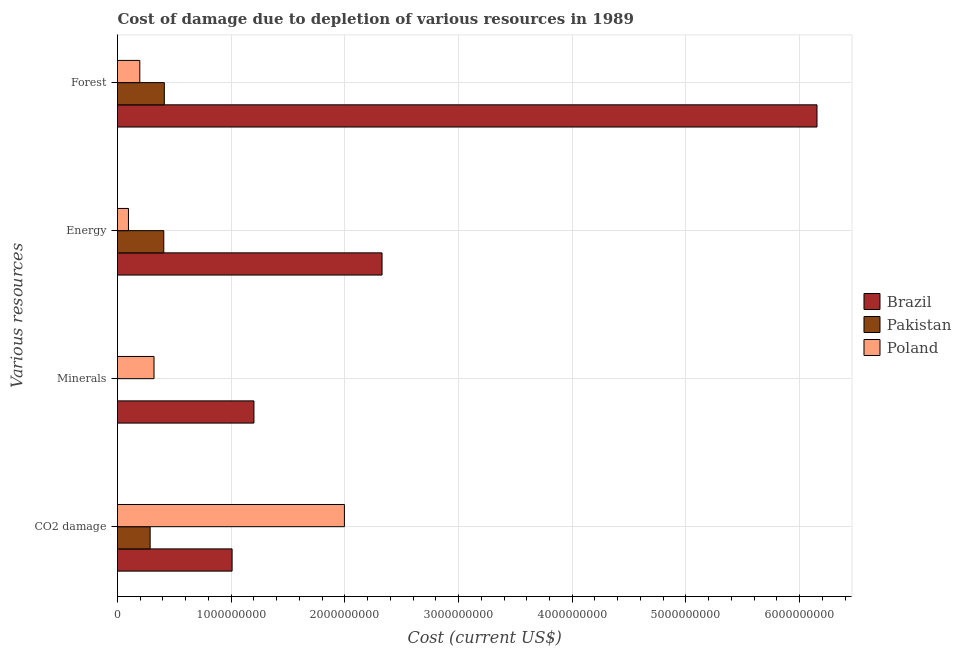How many different coloured bars are there?
Offer a very short reply. 3. How many groups of bars are there?
Provide a short and direct response. 4. Are the number of bars per tick equal to the number of legend labels?
Provide a succinct answer. Yes. How many bars are there on the 3rd tick from the bottom?
Make the answer very short. 3. What is the label of the 1st group of bars from the top?
Give a very brief answer. Forest. What is the cost of damage due to depletion of minerals in Pakistan?
Keep it short and to the point. 2.33e+04. Across all countries, what is the maximum cost of damage due to depletion of energy?
Offer a terse response. 2.33e+09. Across all countries, what is the minimum cost of damage due to depletion of minerals?
Your response must be concise. 2.33e+04. What is the total cost of damage due to depletion of minerals in the graph?
Offer a terse response. 1.52e+09. What is the difference between the cost of damage due to depletion of coal in Poland and that in Pakistan?
Ensure brevity in your answer.  1.71e+09. What is the difference between the cost of damage due to depletion of coal in Pakistan and the cost of damage due to depletion of minerals in Brazil?
Offer a very short reply. -9.13e+08. What is the average cost of damage due to depletion of forests per country?
Your response must be concise. 2.25e+09. What is the difference between the cost of damage due to depletion of minerals and cost of damage due to depletion of coal in Pakistan?
Provide a short and direct response. -2.87e+08. What is the ratio of the cost of damage due to depletion of coal in Poland to that in Brazil?
Give a very brief answer. 1.98. Is the difference between the cost of damage due to depletion of forests in Pakistan and Brazil greater than the difference between the cost of damage due to depletion of energy in Pakistan and Brazil?
Provide a succinct answer. No. What is the difference between the highest and the second highest cost of damage due to depletion of minerals?
Keep it short and to the point. 8.79e+08. What is the difference between the highest and the lowest cost of damage due to depletion of forests?
Your answer should be very brief. 5.96e+09. In how many countries, is the cost of damage due to depletion of energy greater than the average cost of damage due to depletion of energy taken over all countries?
Provide a succinct answer. 1. Is the sum of the cost of damage due to depletion of minerals in Pakistan and Poland greater than the maximum cost of damage due to depletion of coal across all countries?
Provide a short and direct response. No. What does the 1st bar from the top in Minerals represents?
Your response must be concise. Poland. Is it the case that in every country, the sum of the cost of damage due to depletion of coal and cost of damage due to depletion of minerals is greater than the cost of damage due to depletion of energy?
Give a very brief answer. No. How many countries are there in the graph?
Provide a succinct answer. 3. What is the difference between two consecutive major ticks on the X-axis?
Your answer should be compact. 1.00e+09. Does the graph contain grids?
Provide a short and direct response. Yes. What is the title of the graph?
Ensure brevity in your answer.  Cost of damage due to depletion of various resources in 1989 . Does "Australia" appear as one of the legend labels in the graph?
Ensure brevity in your answer.  No. What is the label or title of the X-axis?
Your answer should be very brief. Cost (current US$). What is the label or title of the Y-axis?
Give a very brief answer. Various resources. What is the Cost (current US$) of Brazil in CO2 damage?
Offer a very short reply. 1.01e+09. What is the Cost (current US$) in Pakistan in CO2 damage?
Provide a short and direct response. 2.87e+08. What is the Cost (current US$) in Poland in CO2 damage?
Your response must be concise. 2.00e+09. What is the Cost (current US$) in Brazil in Minerals?
Your answer should be compact. 1.20e+09. What is the Cost (current US$) of Pakistan in Minerals?
Your answer should be very brief. 2.33e+04. What is the Cost (current US$) in Poland in Minerals?
Offer a terse response. 3.21e+08. What is the Cost (current US$) in Brazil in Energy?
Provide a short and direct response. 2.33e+09. What is the Cost (current US$) of Pakistan in Energy?
Your answer should be very brief. 4.07e+08. What is the Cost (current US$) of Poland in Energy?
Provide a succinct answer. 9.63e+07. What is the Cost (current US$) in Brazil in Forest?
Offer a terse response. 6.15e+09. What is the Cost (current US$) of Pakistan in Forest?
Provide a succinct answer. 4.12e+08. What is the Cost (current US$) of Poland in Forest?
Your response must be concise. 1.96e+08. Across all Various resources, what is the maximum Cost (current US$) in Brazil?
Give a very brief answer. 6.15e+09. Across all Various resources, what is the maximum Cost (current US$) of Pakistan?
Your answer should be very brief. 4.12e+08. Across all Various resources, what is the maximum Cost (current US$) in Poland?
Your response must be concise. 2.00e+09. Across all Various resources, what is the minimum Cost (current US$) of Brazil?
Offer a terse response. 1.01e+09. Across all Various resources, what is the minimum Cost (current US$) of Pakistan?
Offer a terse response. 2.33e+04. Across all Various resources, what is the minimum Cost (current US$) in Poland?
Your answer should be compact. 9.63e+07. What is the total Cost (current US$) of Brazil in the graph?
Keep it short and to the point. 1.07e+1. What is the total Cost (current US$) of Pakistan in the graph?
Your answer should be very brief. 1.11e+09. What is the total Cost (current US$) in Poland in the graph?
Your response must be concise. 2.61e+09. What is the difference between the Cost (current US$) of Brazil in CO2 damage and that in Minerals?
Your answer should be compact. -1.92e+08. What is the difference between the Cost (current US$) in Pakistan in CO2 damage and that in Minerals?
Make the answer very short. 2.87e+08. What is the difference between the Cost (current US$) in Poland in CO2 damage and that in Minerals?
Your response must be concise. 1.67e+09. What is the difference between the Cost (current US$) in Brazil in CO2 damage and that in Energy?
Offer a very short reply. -1.32e+09. What is the difference between the Cost (current US$) in Pakistan in CO2 damage and that in Energy?
Keep it short and to the point. -1.20e+08. What is the difference between the Cost (current US$) in Poland in CO2 damage and that in Energy?
Your response must be concise. 1.90e+09. What is the difference between the Cost (current US$) in Brazil in CO2 damage and that in Forest?
Ensure brevity in your answer.  -5.15e+09. What is the difference between the Cost (current US$) in Pakistan in CO2 damage and that in Forest?
Your answer should be very brief. -1.25e+08. What is the difference between the Cost (current US$) of Poland in CO2 damage and that in Forest?
Keep it short and to the point. 1.80e+09. What is the difference between the Cost (current US$) in Brazil in Minerals and that in Energy?
Give a very brief answer. -1.13e+09. What is the difference between the Cost (current US$) in Pakistan in Minerals and that in Energy?
Provide a short and direct response. -4.07e+08. What is the difference between the Cost (current US$) in Poland in Minerals and that in Energy?
Make the answer very short. 2.25e+08. What is the difference between the Cost (current US$) in Brazil in Minerals and that in Forest?
Offer a terse response. -4.95e+09. What is the difference between the Cost (current US$) in Pakistan in Minerals and that in Forest?
Provide a short and direct response. -4.12e+08. What is the difference between the Cost (current US$) in Poland in Minerals and that in Forest?
Provide a short and direct response. 1.25e+08. What is the difference between the Cost (current US$) in Brazil in Energy and that in Forest?
Your answer should be compact. -3.83e+09. What is the difference between the Cost (current US$) in Pakistan in Energy and that in Forest?
Provide a succinct answer. -4.92e+06. What is the difference between the Cost (current US$) of Poland in Energy and that in Forest?
Your response must be concise. -9.99e+07. What is the difference between the Cost (current US$) in Brazil in CO2 damage and the Cost (current US$) in Pakistan in Minerals?
Ensure brevity in your answer.  1.01e+09. What is the difference between the Cost (current US$) in Brazil in CO2 damage and the Cost (current US$) in Poland in Minerals?
Give a very brief answer. 6.87e+08. What is the difference between the Cost (current US$) of Pakistan in CO2 damage and the Cost (current US$) of Poland in Minerals?
Your response must be concise. -3.41e+07. What is the difference between the Cost (current US$) of Brazil in CO2 damage and the Cost (current US$) of Pakistan in Energy?
Offer a very short reply. 6.01e+08. What is the difference between the Cost (current US$) in Brazil in CO2 damage and the Cost (current US$) in Poland in Energy?
Offer a terse response. 9.12e+08. What is the difference between the Cost (current US$) of Pakistan in CO2 damage and the Cost (current US$) of Poland in Energy?
Your response must be concise. 1.91e+08. What is the difference between the Cost (current US$) of Brazil in CO2 damage and the Cost (current US$) of Pakistan in Forest?
Give a very brief answer. 5.96e+08. What is the difference between the Cost (current US$) in Brazil in CO2 damage and the Cost (current US$) in Poland in Forest?
Your answer should be very brief. 8.12e+08. What is the difference between the Cost (current US$) of Pakistan in CO2 damage and the Cost (current US$) of Poland in Forest?
Make the answer very short. 9.09e+07. What is the difference between the Cost (current US$) in Brazil in Minerals and the Cost (current US$) in Pakistan in Energy?
Offer a terse response. 7.93e+08. What is the difference between the Cost (current US$) in Brazil in Minerals and the Cost (current US$) in Poland in Energy?
Your response must be concise. 1.10e+09. What is the difference between the Cost (current US$) of Pakistan in Minerals and the Cost (current US$) of Poland in Energy?
Your answer should be compact. -9.63e+07. What is the difference between the Cost (current US$) of Brazil in Minerals and the Cost (current US$) of Pakistan in Forest?
Ensure brevity in your answer.  7.88e+08. What is the difference between the Cost (current US$) of Brazil in Minerals and the Cost (current US$) of Poland in Forest?
Keep it short and to the point. 1.00e+09. What is the difference between the Cost (current US$) of Pakistan in Minerals and the Cost (current US$) of Poland in Forest?
Your response must be concise. -1.96e+08. What is the difference between the Cost (current US$) in Brazil in Energy and the Cost (current US$) in Pakistan in Forest?
Ensure brevity in your answer.  1.92e+09. What is the difference between the Cost (current US$) in Brazil in Energy and the Cost (current US$) in Poland in Forest?
Keep it short and to the point. 2.13e+09. What is the difference between the Cost (current US$) in Pakistan in Energy and the Cost (current US$) in Poland in Forest?
Offer a terse response. 2.11e+08. What is the average Cost (current US$) of Brazil per Various resources?
Your answer should be very brief. 2.67e+09. What is the average Cost (current US$) in Pakistan per Various resources?
Keep it short and to the point. 2.77e+08. What is the average Cost (current US$) in Poland per Various resources?
Offer a terse response. 6.52e+08. What is the difference between the Cost (current US$) in Brazil and Cost (current US$) in Pakistan in CO2 damage?
Give a very brief answer. 7.21e+08. What is the difference between the Cost (current US$) of Brazil and Cost (current US$) of Poland in CO2 damage?
Your response must be concise. -9.88e+08. What is the difference between the Cost (current US$) in Pakistan and Cost (current US$) in Poland in CO2 damage?
Give a very brief answer. -1.71e+09. What is the difference between the Cost (current US$) in Brazil and Cost (current US$) in Pakistan in Minerals?
Your answer should be compact. 1.20e+09. What is the difference between the Cost (current US$) of Brazil and Cost (current US$) of Poland in Minerals?
Give a very brief answer. 8.79e+08. What is the difference between the Cost (current US$) in Pakistan and Cost (current US$) in Poland in Minerals?
Give a very brief answer. -3.21e+08. What is the difference between the Cost (current US$) in Brazil and Cost (current US$) in Pakistan in Energy?
Provide a short and direct response. 1.92e+09. What is the difference between the Cost (current US$) in Brazil and Cost (current US$) in Poland in Energy?
Your response must be concise. 2.23e+09. What is the difference between the Cost (current US$) of Pakistan and Cost (current US$) of Poland in Energy?
Provide a short and direct response. 3.11e+08. What is the difference between the Cost (current US$) of Brazil and Cost (current US$) of Pakistan in Forest?
Your response must be concise. 5.74e+09. What is the difference between the Cost (current US$) of Brazil and Cost (current US$) of Poland in Forest?
Your answer should be compact. 5.96e+09. What is the difference between the Cost (current US$) of Pakistan and Cost (current US$) of Poland in Forest?
Keep it short and to the point. 2.16e+08. What is the ratio of the Cost (current US$) in Brazil in CO2 damage to that in Minerals?
Provide a short and direct response. 0.84. What is the ratio of the Cost (current US$) in Pakistan in CO2 damage to that in Minerals?
Keep it short and to the point. 1.23e+04. What is the ratio of the Cost (current US$) in Poland in CO2 damage to that in Minerals?
Make the answer very short. 6.21. What is the ratio of the Cost (current US$) of Brazil in CO2 damage to that in Energy?
Ensure brevity in your answer.  0.43. What is the ratio of the Cost (current US$) in Pakistan in CO2 damage to that in Energy?
Offer a terse response. 0.71. What is the ratio of the Cost (current US$) of Poland in CO2 damage to that in Energy?
Keep it short and to the point. 20.72. What is the ratio of the Cost (current US$) of Brazil in CO2 damage to that in Forest?
Ensure brevity in your answer.  0.16. What is the ratio of the Cost (current US$) of Pakistan in CO2 damage to that in Forest?
Your answer should be compact. 0.7. What is the ratio of the Cost (current US$) in Poland in CO2 damage to that in Forest?
Provide a short and direct response. 10.17. What is the ratio of the Cost (current US$) in Brazil in Minerals to that in Energy?
Offer a very short reply. 0.52. What is the ratio of the Cost (current US$) in Pakistan in Minerals to that in Energy?
Offer a very short reply. 0. What is the ratio of the Cost (current US$) in Poland in Minerals to that in Energy?
Offer a terse response. 3.33. What is the ratio of the Cost (current US$) of Brazil in Minerals to that in Forest?
Provide a short and direct response. 0.2. What is the ratio of the Cost (current US$) in Poland in Minerals to that in Forest?
Your response must be concise. 1.64. What is the ratio of the Cost (current US$) of Brazil in Energy to that in Forest?
Give a very brief answer. 0.38. What is the ratio of the Cost (current US$) of Pakistan in Energy to that in Forest?
Make the answer very short. 0.99. What is the ratio of the Cost (current US$) of Poland in Energy to that in Forest?
Give a very brief answer. 0.49. What is the difference between the highest and the second highest Cost (current US$) of Brazil?
Offer a very short reply. 3.83e+09. What is the difference between the highest and the second highest Cost (current US$) of Pakistan?
Your answer should be very brief. 4.92e+06. What is the difference between the highest and the second highest Cost (current US$) in Poland?
Your response must be concise. 1.67e+09. What is the difference between the highest and the lowest Cost (current US$) in Brazil?
Your answer should be very brief. 5.15e+09. What is the difference between the highest and the lowest Cost (current US$) of Pakistan?
Offer a very short reply. 4.12e+08. What is the difference between the highest and the lowest Cost (current US$) of Poland?
Offer a terse response. 1.90e+09. 